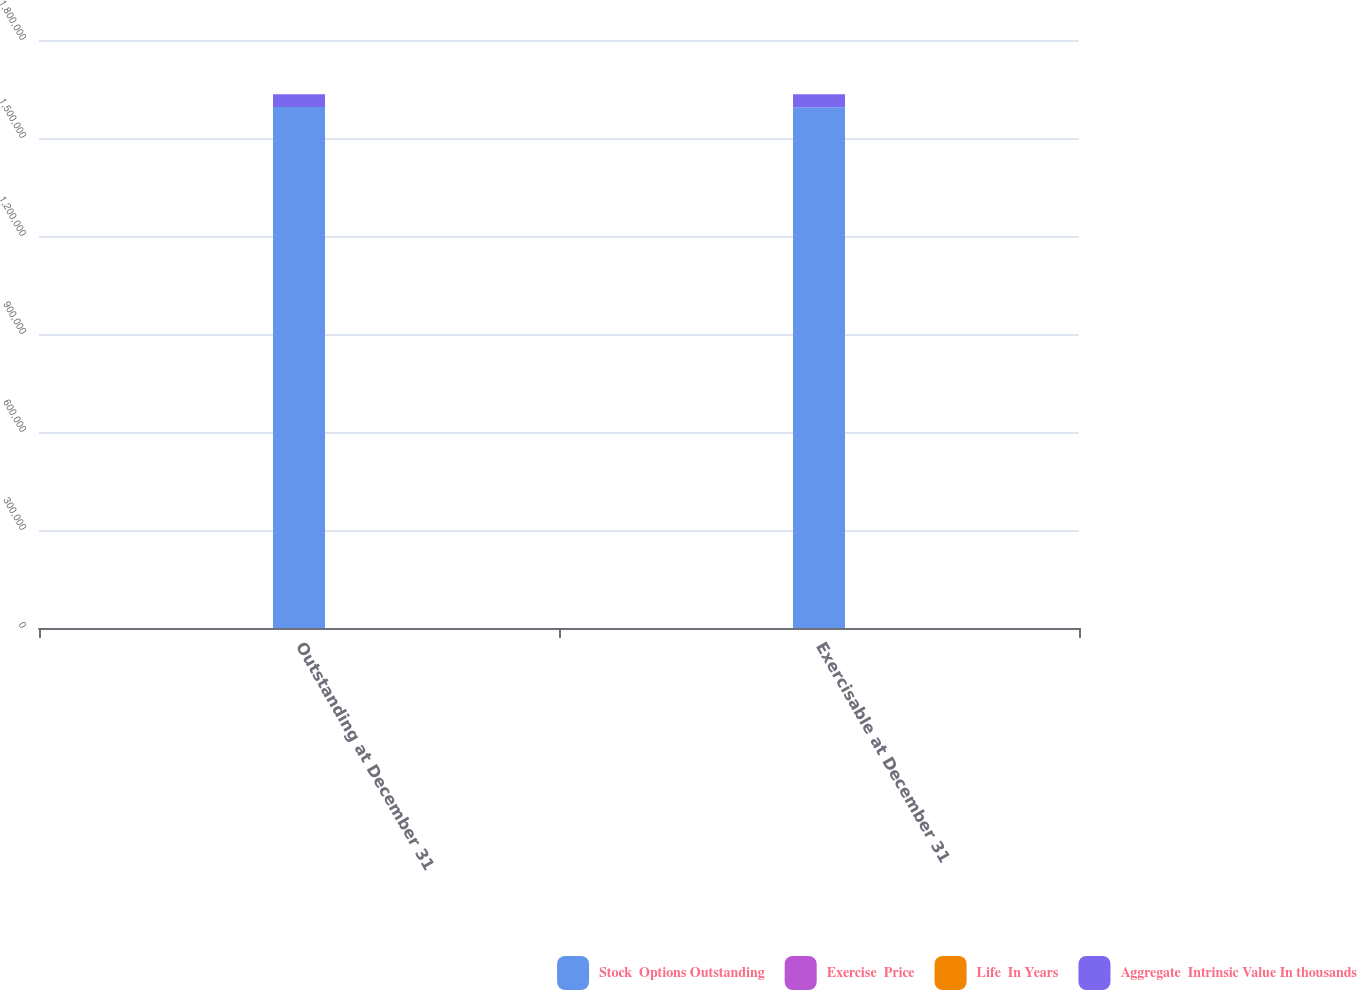<chart> <loc_0><loc_0><loc_500><loc_500><stacked_bar_chart><ecel><fcel>Outstanding at December 31<fcel>Exercisable at December 31<nl><fcel>Stock  Options Outstanding<fcel>1.59459e+06<fcel>1.59415e+06<nl><fcel>Exercise  Price<fcel>139.6<fcel>139.6<nl><fcel>Life  In Years<fcel>1.5<fcel>1.5<nl><fcel>Aggregate  Intrinsic Value In thousands<fcel>39326<fcel>39305<nl></chart> 